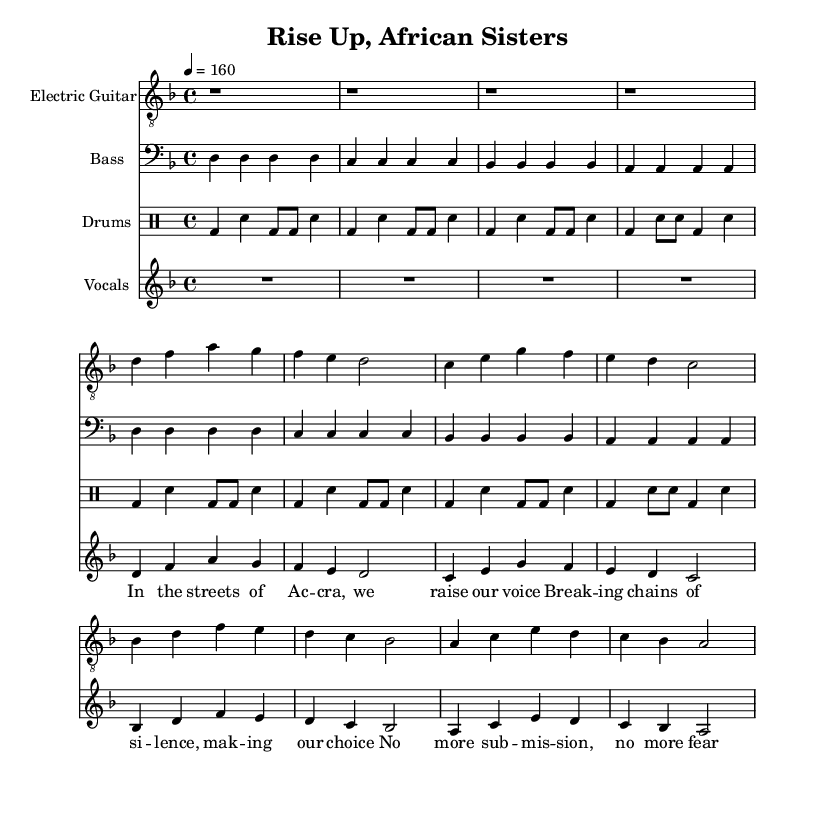What is the key signature of this music? The key signature is two flats (B-flat and E-flat), which indicates that the music is in D minor. This can be verified by looking at the notes and the context of the key signature specified at the beginning of the score.
Answer: D minor What is the time signature of the piece? The time signature indicated in the music is 4/4, meaning there are four beats in each measure and the quarter note gets one beat. This is usually displayed right after the key signature at the beginning of the score.
Answer: 4/4 What is the tempo marking of this music? The tempo marking is indicated as "tempo 4 equals 160," which means the piece should be played at a speed of 160 beats per minute. This is significant for understanding the energy and pace of the piece.
Answer: 160 How many measures are there in the intro? The intro consists of four measures of rest before the verse starts, which can be counted directly from the multiple rest symbols (r1) shown at the beginning of the score.
Answer: 4 What themes are expressed in the lyrics? The lyrics focus on themes of empowerment, resistance, and taking action against oppression. This is derived from interpreting the words and their emotional weight in the lyrics presented alongside the vocal staff.
Answer: Empowerment What type of drum pattern is used in the intro? The intro drum pattern uses a repeated combination of bass drum hits and snare hits, which creates a driving rhythmic foundation typical in punk music. This pattern can be examined in the drum staff section.
Answer: Bass and snare How would you describe the overall style of this punk song? The overall style can be described as energetic and rebellious, characterized by its fast tempo, strong rhythms, and empowering lyrics, which collectively align with the essence of feminist punk rock. This interpretation is gathered from the tempo, lyrics, and typical punk characteristics displayed in the score.
Answer: Energetic and rebellious 